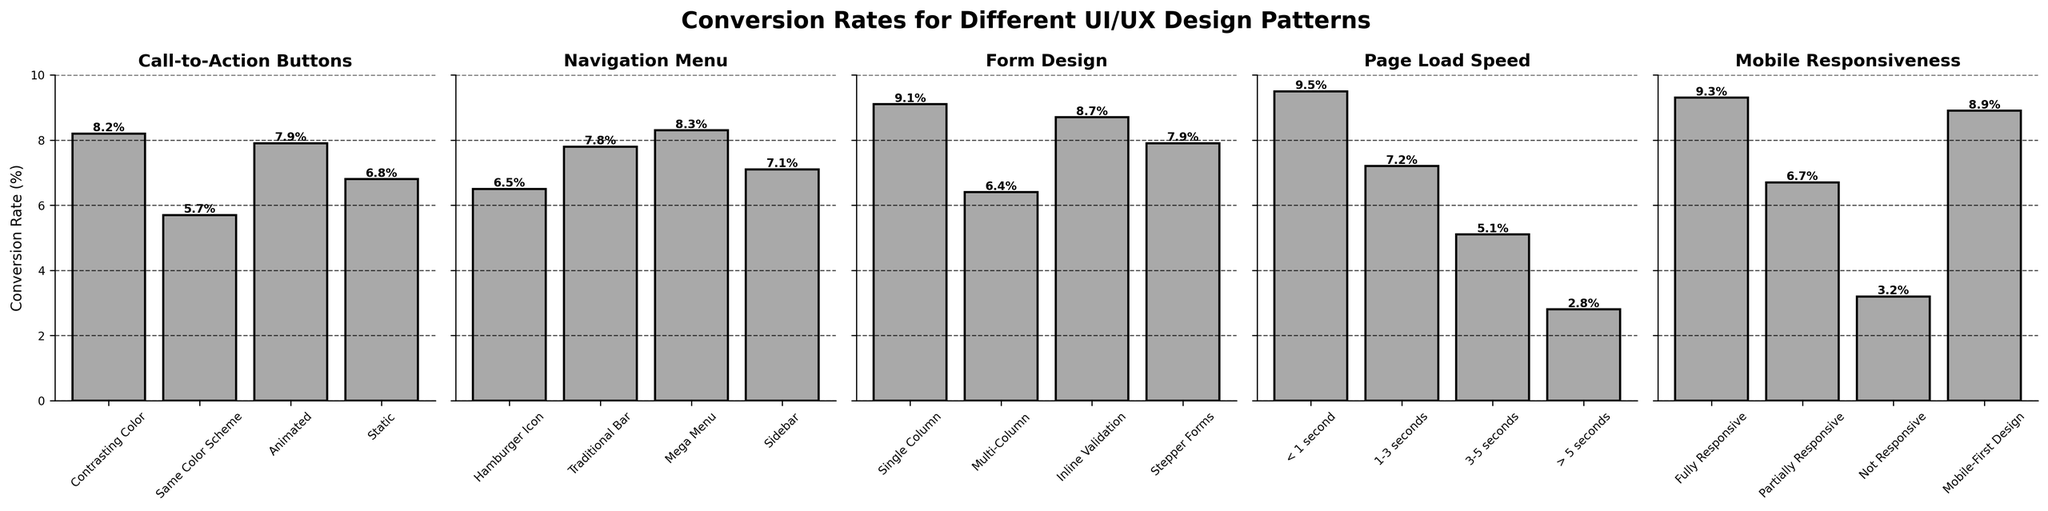Which UI design pattern for Call-to-Action Buttons has the highest conversion rate? By observing the bars in the "Call-to-Action Buttons" subplot, the highest bar represents "Contrasting Color," which has a conversion rate of 8.2%.
Answer: Contrasting Color What's the total conversion rate for Navigation Menu patterns? Sum the conversion rates for all elements under "Navigation Menu": 6.5 (Hamburger Icon) + 7.8 (Traditional Bar) + 8.3 (Mega Menu) + 7.1 (Sidebar) = 29.7%.
Answer: 29.7% What is the difference in conversion rates between Single Column and Multi-Column Form Designs? Subtract the conversion rate of Multi-Column (6.4%) from Single Column (9.1%): 9.1 - 6.4 = 2.7%.
Answer: 2.7% Does Mobile-First Design or Fully Responsive design have a higher conversion rate? By comparing the bars of "Mobile-First Design" (8.9%) and "Fully Responsive" (9.3%), it is clear that "Fully Responsive" has a higher conversion rate.
Answer: Fully Responsive What is the average conversion rate for Page Load Speed under 3 seconds? Calculate the average conversion rate for "< 1 second" (9.5%) and "1-3 seconds" (7.2%): (9.5 + 7.2) / 2 = 8.35%.
Answer: 8.35% Which design pattern among the displayed subplots has the lowest conversion rate? By observing all the subplots, the lowest bar is in the "Page Load Speed" subplot for "> 5 seconds," which has a conversion rate of 2.8%.
Answer: Page Load Speed (> 5 seconds) How does the conversion rate of Animated Call-to-Action Buttons compare to that of an Inline Validation Form Design? Comparing the bars, "Animated" Call-to-Action Buttons have a conversion rate of 7.9%, while "Inline Validation" for Form Design has a conversion rate of 8.7%. Hence, Inline Validation performs better.
Answer: Inline Validation Which element in the Navigation Menu design pattern has the highest conversion rate, and what is the value? By examining the bars in the "Navigation Menu" subplot, the highest bar is "Mega Menu" with a conversion rate of 8.3%.
Answer: Mega Menu, 8.3% Is the conversion rate for a Non-Responsive Mobile Design greater than that of the Page Load Speed of 3-5 seconds? Comparing the two bars, the conversion rate for Non-Responsive Mobile Design is 3.2%, while for 3-5 seconds Page Load Speed is 5.1%. Therefore, the conversion rate for Non-Responsive Mobile Design is not greater.
Answer: No What is the difference in conversion rates between Static and Contrasting Color Call-to-Action Buttons? Subtract the conversion rate of Static (6.8%) from Contrasting Color (8.2%): 8.2 - 6.8 = 1.4%.
Answer: 1.4% 